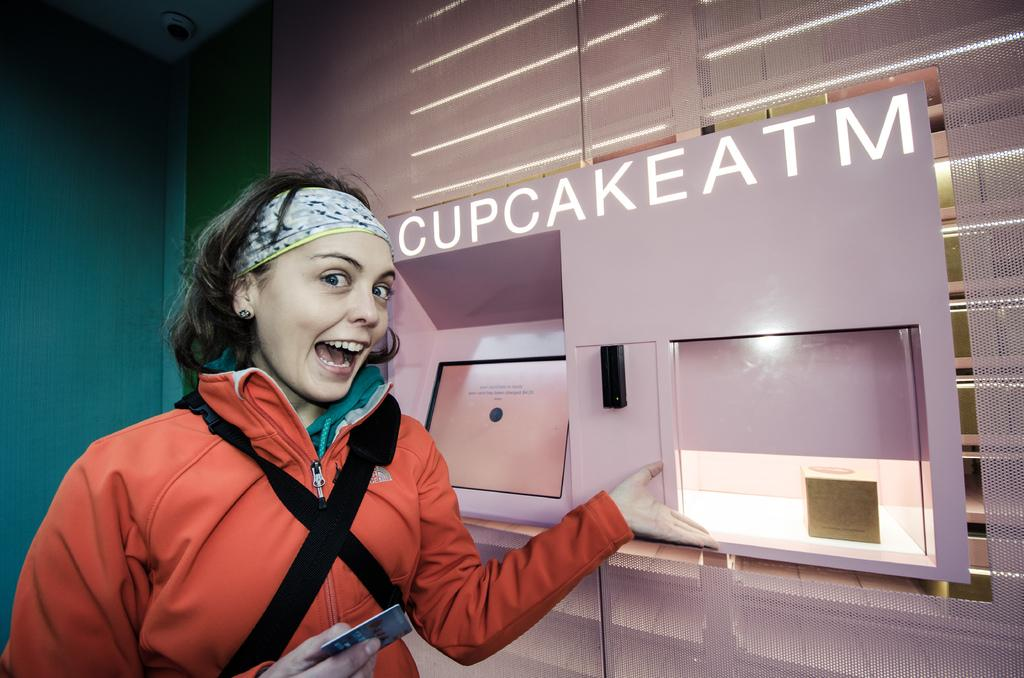<image>
Present a compact description of the photo's key features. A deliriously happy woman enjoys using the Cupcake ATM. 